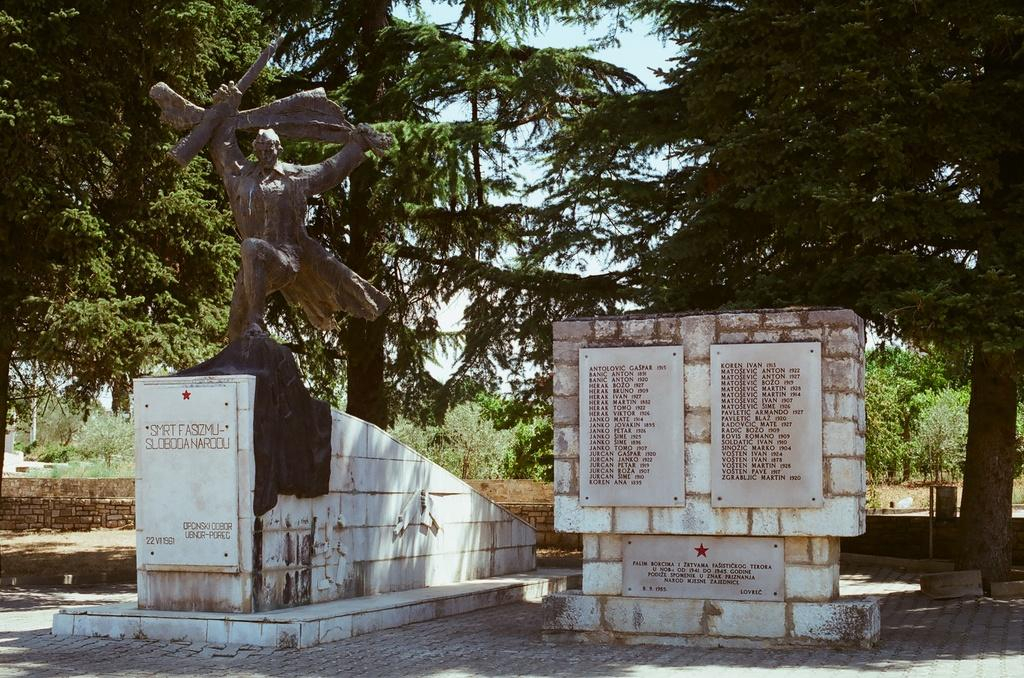What is the main subject in the image? There is a statue in the image. What other elements can be seen in the image? There are trees, the sky, plants, and white color tiles visible in the image. What type of drug is being sold by the statue in the image? There is no drug being sold by the statue in the image, as the statue is an inanimate object and cannot engage in such activities. 